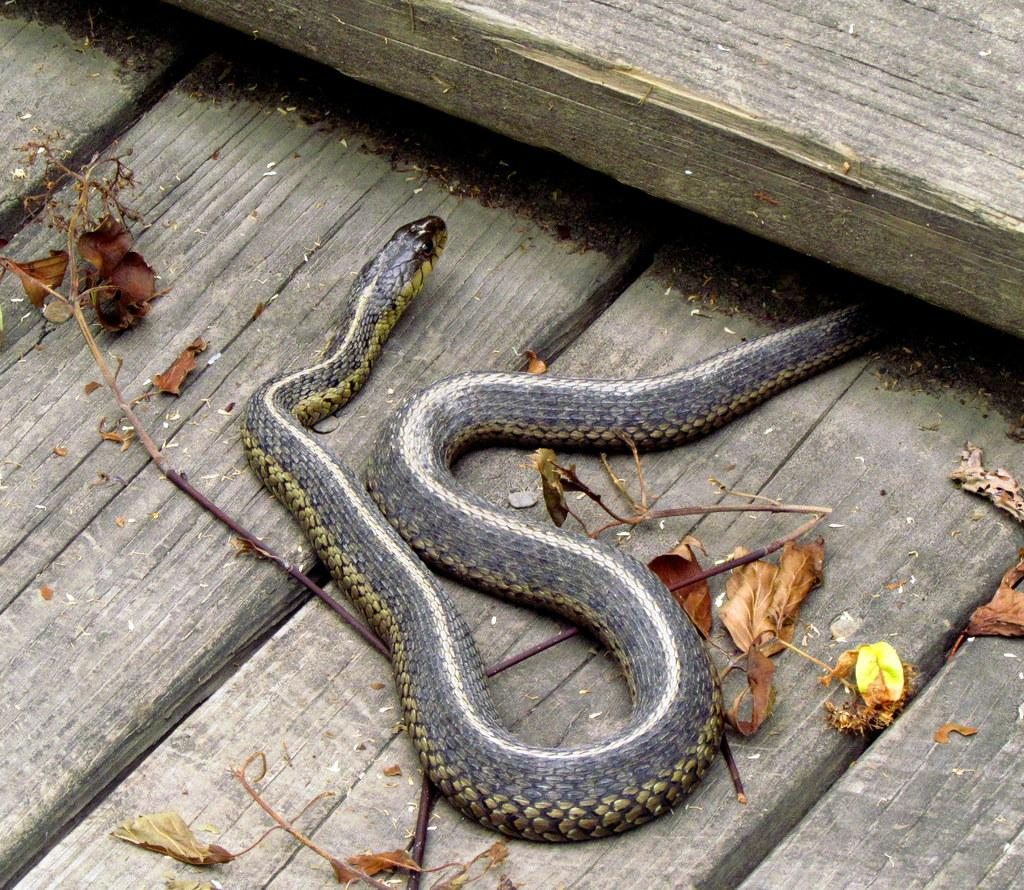What type of animal can be seen on the ground in the image? There is a snake on the ground in the image. What else can be found on the ground in the image? Dry leaves and plants are present on the ground. Can you describe the environment in the image? The image shows a ground with dry leaves, plants, and a snake. How many chairs are in the bedroom in the image? There is no bedroom or chairs present in the image; it features a snake on the ground with dry leaves and plants. 